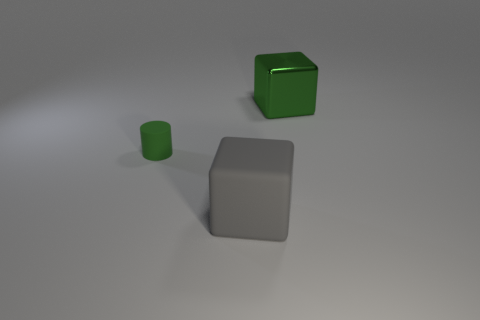How many objects are in the image, and can you describe their shapes? There are three objects in the image: a large matte cube, a smaller shiny cylinder, and a medium-sized matte cuboid. 